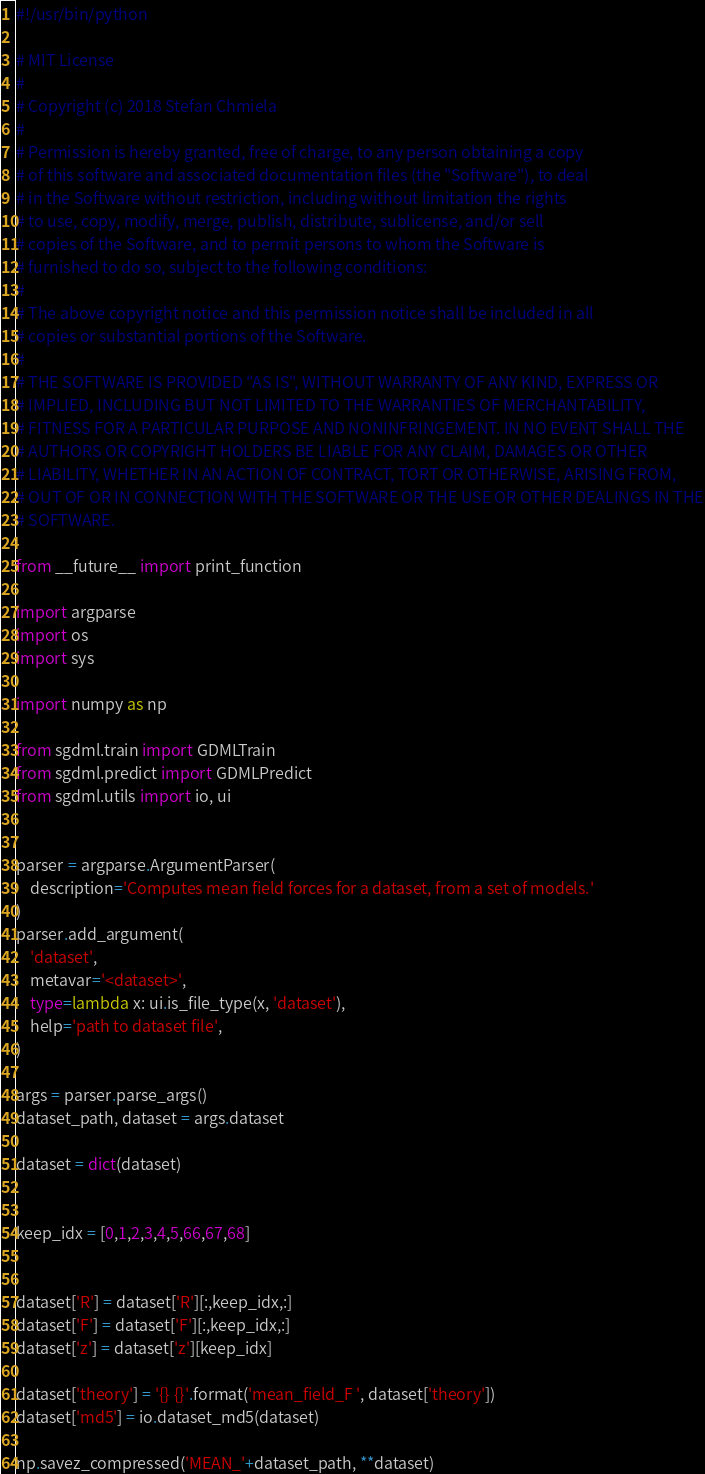Convert code to text. <code><loc_0><loc_0><loc_500><loc_500><_Python_>#!/usr/bin/python

# MIT License
#
# Copyright (c) 2018 Stefan Chmiela
#
# Permission is hereby granted, free of charge, to any person obtaining a copy
# of this software and associated documentation files (the "Software"), to deal
# in the Software without restriction, including without limitation the rights
# to use, copy, modify, merge, publish, distribute, sublicense, and/or sell
# copies of the Software, and to permit persons to whom the Software is
# furnished to do so, subject to the following conditions:
#
# The above copyright notice and this permission notice shall be included in all
# copies or substantial portions of the Software.
#
# THE SOFTWARE IS PROVIDED "AS IS", WITHOUT WARRANTY OF ANY KIND, EXPRESS OR
# IMPLIED, INCLUDING BUT NOT LIMITED TO THE WARRANTIES OF MERCHANTABILITY,
# FITNESS FOR A PARTICULAR PURPOSE AND NONINFRINGEMENT. IN NO EVENT SHALL THE
# AUTHORS OR COPYRIGHT HOLDERS BE LIABLE FOR ANY CLAIM, DAMAGES OR OTHER
# LIABILITY, WHETHER IN AN ACTION OF CONTRACT, TORT OR OTHERWISE, ARISING FROM,
# OUT OF OR IN CONNECTION WITH THE SOFTWARE OR THE USE OR OTHER DEALINGS IN THE
# SOFTWARE.

from __future__ import print_function

import argparse
import os
import sys

import numpy as np

from sgdml.train import GDMLTrain
from sgdml.predict import GDMLPredict
from sgdml.utils import io, ui


parser = argparse.ArgumentParser(
    description='Computes mean field forces for a dataset, from a set of models.'
)
parser.add_argument(
    'dataset',
    metavar='<dataset>',
    type=lambda x: ui.is_file_type(x, 'dataset'),
    help='path to dataset file',
)

args = parser.parse_args()
dataset_path, dataset = args.dataset

dataset = dict(dataset)


keep_idx = [0,1,2,3,4,5,66,67,68]


dataset['R'] = dataset['R'][:,keep_idx,:]
dataset['F'] = dataset['F'][:,keep_idx,:]
dataset['z'] = dataset['z'][keep_idx]

dataset['theory'] = '{} {}'.format('mean_field_F ', dataset['theory'])
dataset['md5'] = io.dataset_md5(dataset)

np.savez_compressed('MEAN_'+dataset_path, **dataset)</code> 